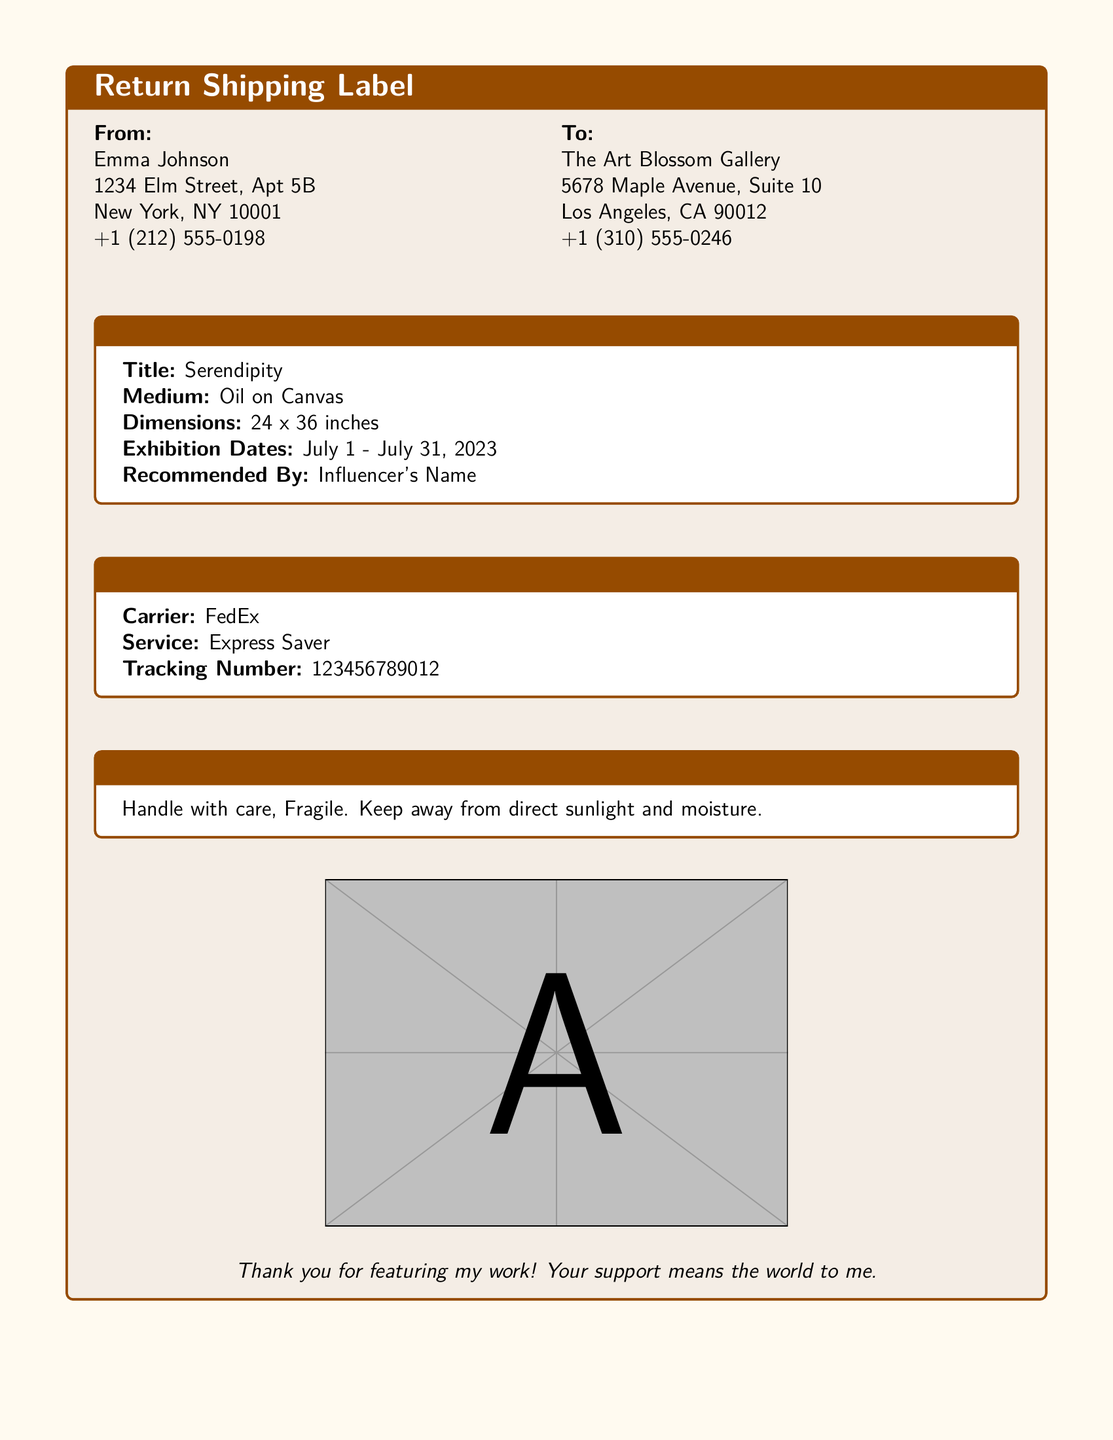What is the sender's name? The sender's name is listed at the top of the document under "From."
Answer: Emma Johnson What is the medium of the artwork? The medium can be found in the "Artwork Details" section.
Answer: Oil on Canvas What are the exhibition dates? The exhibition dates are specified under "Artwork Details."
Answer: July 1 - July 31, 2023 What is the shipping carrier? The carrier is identified in the "Shipping Information" section.
Answer: FedEx What is the tracking number? The tracking number can be found in the "Shipping Information" section.
Answer: 123456789012 Why is the artwork being returned? The document implies the artwork is being sent back due to the influencer's recommendation.
Answer: Influencer's recommendation What are the dimensions of the artwork? The dimensions are provided in the "Artwork Details" section.
Answer: 24 x 36 inches What is the service type for shipping? The service type is indicated in the "Shipping Information" section.
Answer: Express Saver What handling instructions are given? The handling instructions are explained in the "Handling Instructions" box.
Answer: Handle with care, Fragile 